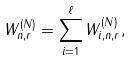Convert formula to latex. <formula><loc_0><loc_0><loc_500><loc_500>W _ { n , r } ^ { ( N ) } = \sum _ { i = 1 } ^ { \ell } W _ { i , n , r } ^ { ( N ) } ,</formula> 